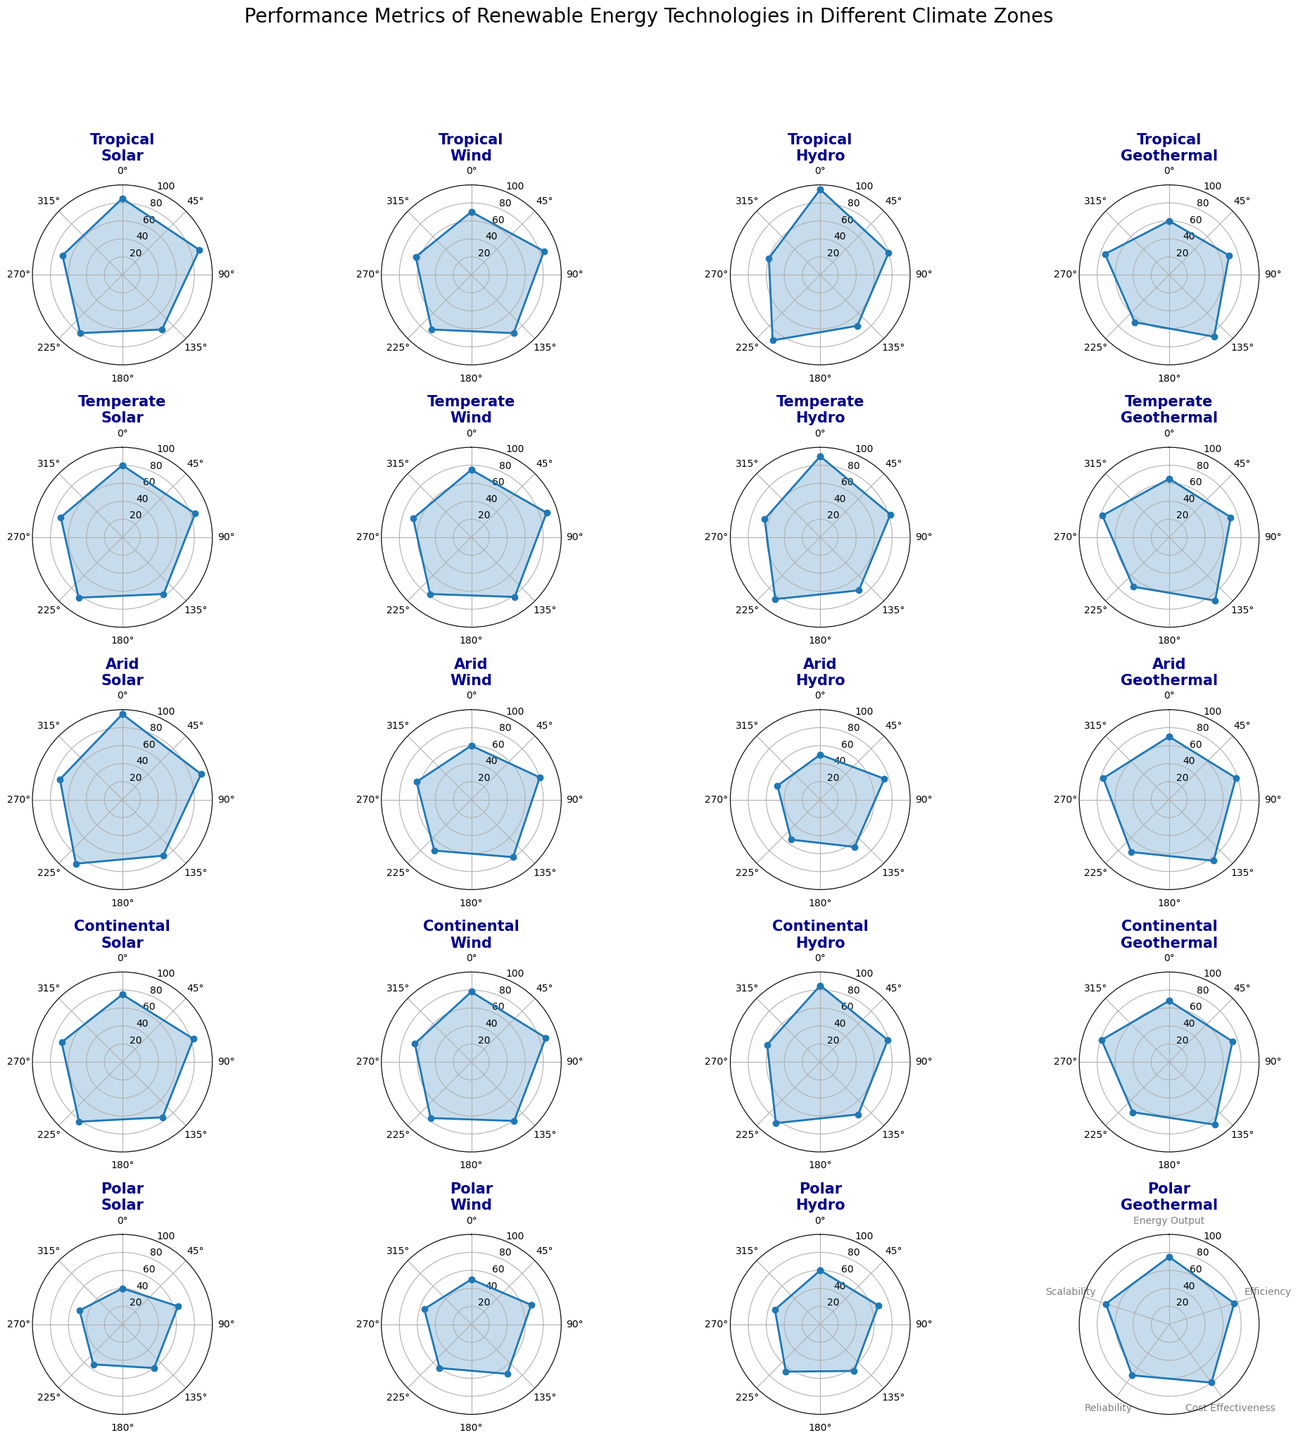Which technology has the highest Energy Output in a Tropical climate zone? For the Tropical climate zone, the Energy Output metrics need to be compared for each technology: Solar (85), Wind (70), Hydro (95), and Geothermal (60). Hydro has the highest Energy Output of 95.
Answer: Hydro Which climate zone exhibits the highest average Efficiency for solar technology? Efficiency metrics for Solar technology across the climate zones are: Tropical (90), Temperate (85), Arid (92), Continental (83), Polar (65). The average Efficiency for each zone can be calculated and compared. The highest value is from Arid (92).
Answer: Arid Between Wind and Geothermal technologies in the Continental climate zone, which is more reliable? For the Continental zone, Reliability metrics need to be compared for Wind (77) and Geothermal (69). Wind technology has a higher Reliability of 77.
Answer: Wind What is the sum of the Scalability metrics for Hydro technology in all climate zones? Scalability metrics for Hydro technology in each zone are: Tropical (60), Temperate (65), Arid (50), Continental (62), Polar (53). Adding them gives 60 + 65 + 50 + 62 + 53 = 290.
Answer: 290 Which technology has the least Cost Effectiveness in a Polar climate zone? In the Polar zone, Cost Effectiveness for each technology needs to be compared: Solar (60), Wind (68), Hydro (64), Geothermal (80). Solar has the least Cost Effectiveness of 60.
Answer: Solar How does the Efficiency of Solar technology in an Arid climate zone compare to Efficiency of Wind technology in the same zone? Efficiency metrics in Arid for Solar is 92, and for Wind is 80. Solar technology is more efficient with a value of 92 compared to Wind's 80.
Answer: Solar What is the average Reliability of Geothermal technology across all climate zones? Reliability metrics for Geothermal in each zone: Tropical (65), Temperate (68), Arid (72), Continental (69), Polar (70). Average Reliability = (65 + 68 + 72 + 69 + 70) / 5 = 68.8.
Answer: 68.8 What is the difference in Energy Output between Wind technology in the Tropical and Continental climate zones? Energy Output for Wind in Tropical is 70, and in Continental is 78. The difference is 78 - 70 = 8.
Answer: 8 